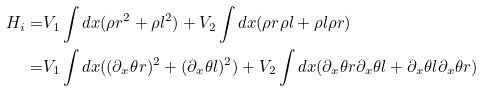<formula> <loc_0><loc_0><loc_500><loc_500>H _ { i } = & V _ { 1 } \int d x ( \rho r ^ { 2 } + \rho l ^ { 2 } ) + V _ { 2 } \int d x ( \rho r \rho l + \rho l \rho r ) \\ = & V _ { 1 } \int d x ( ( \partial _ { x } \theta r ) ^ { 2 } + ( \partial _ { x } \theta l ) ^ { 2 } ) + V _ { 2 } \int d x ( \partial _ { x } \theta r \partial _ { x } \theta l + \partial _ { x } \theta l \partial _ { x } \theta r )</formula> 